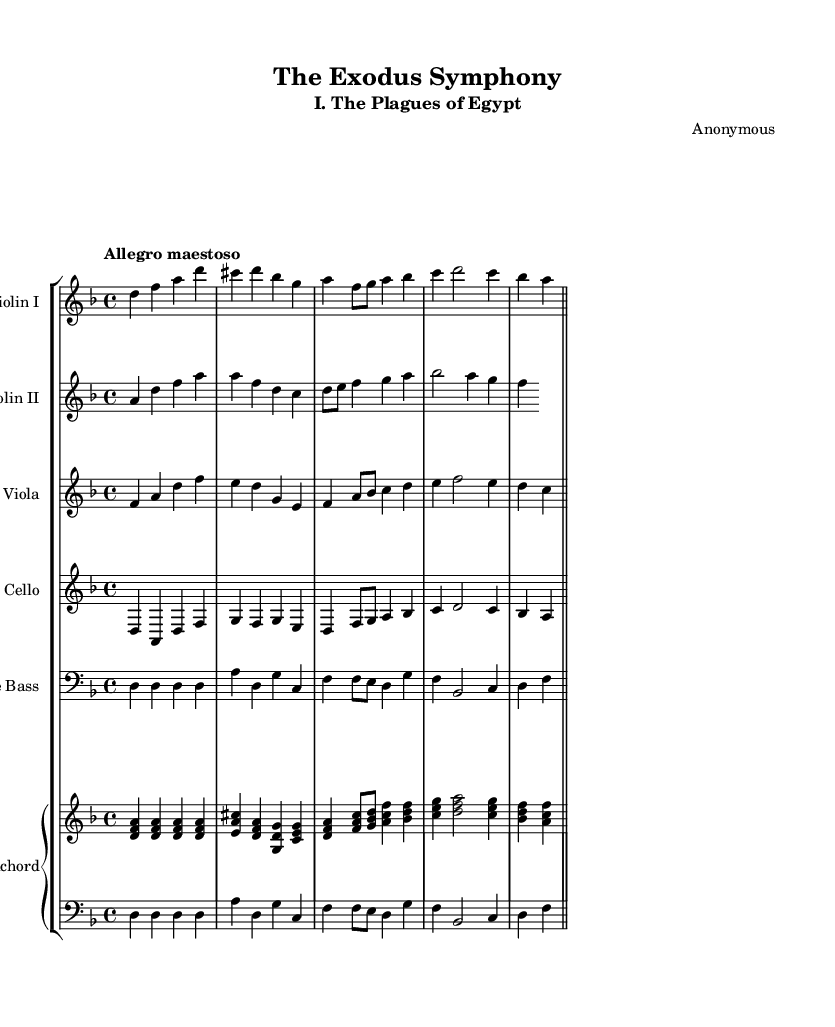What is the key signature of this music? The key signature is indicated at the beginning of the score, which shows two flats (B flat and E flat). This means the key is D minor.
Answer: D minor What is the time signature of this music? The time signature is shown at the beginning of the piece as 4/4, which means there are four beats per measure and the quarter note gets one beat.
Answer: 4/4 What is the tempo marking for this piece? The tempo marking is located above the staff, stating "Allegro maestoso," which indicates a fast and majestic tempo.
Answer: Allegro maestoso How many instruments are included in this symphony? The number of instrument staves shows five distinct instruments: Violin I, Violin II, Viola, Cello, and Double Bass, plus a Harpsichord, making it a total of six.
Answer: Six Which biblical event is represented in the symphony's title? The title "The Exodus Symphony" clearly references the event of the Exodus, which involves the Israelites leaving Egypt as told in the Bible.
Answer: Exodus What is the dynamic marking that appears in this symphony? The score does not specify any dynamics in the provided code, indicating that the performance dynamics are left to the interpretation of the performers.
Answer: None specified What musical form does this symphony primarily adopt? The structure of this piece suggests a multi-movement form, typical of symphonies, with distinct sections, which could align with themes found in biblical stories.
Answer: Multi-movement 